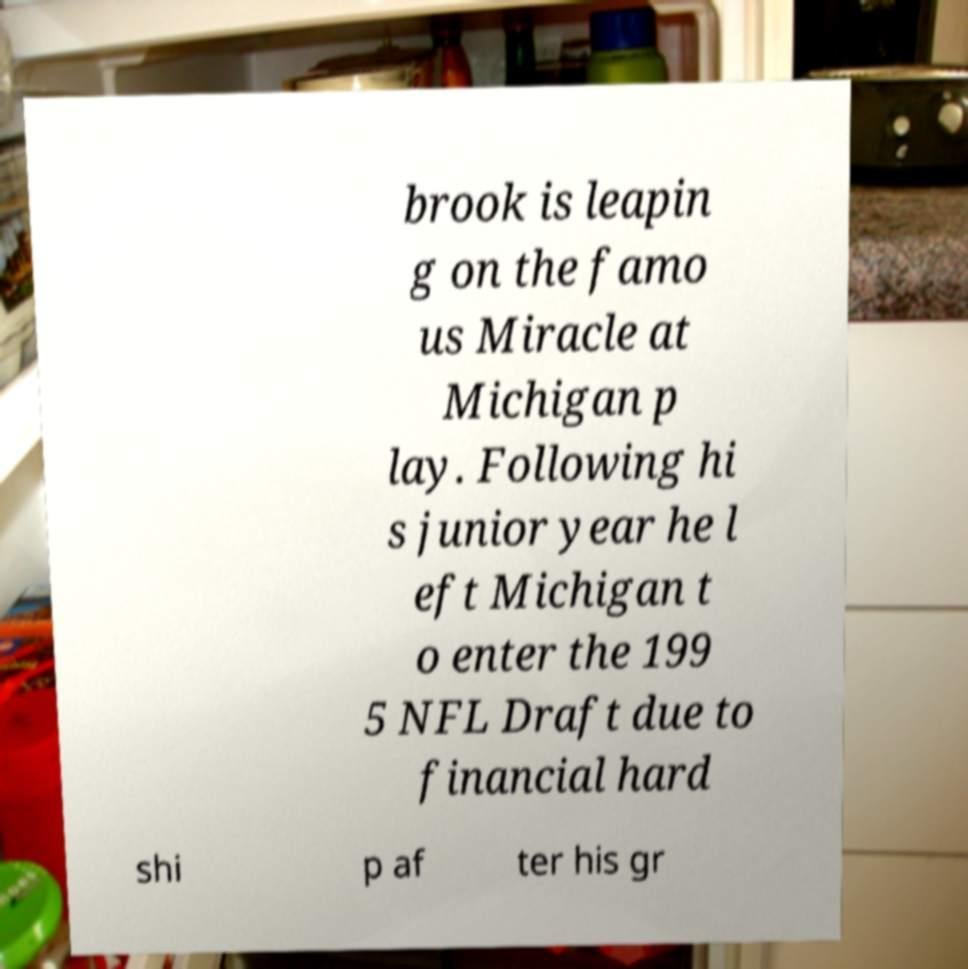There's text embedded in this image that I need extracted. Can you transcribe it verbatim? brook is leapin g on the famo us Miracle at Michigan p lay. Following hi s junior year he l eft Michigan t o enter the 199 5 NFL Draft due to financial hard shi p af ter his gr 